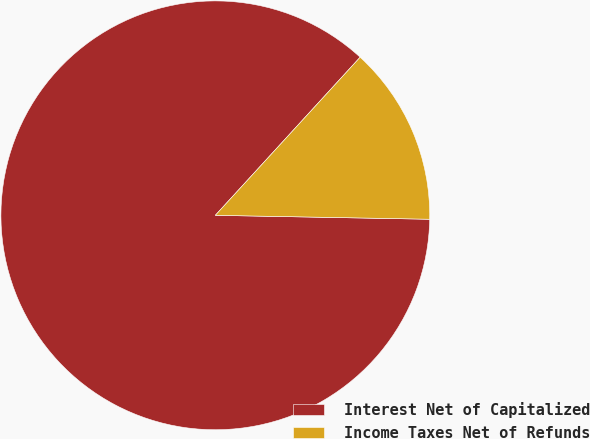<chart> <loc_0><loc_0><loc_500><loc_500><pie_chart><fcel>Interest Net of Capitalized<fcel>Income Taxes Net of Refunds<nl><fcel>86.51%<fcel>13.49%<nl></chart> 